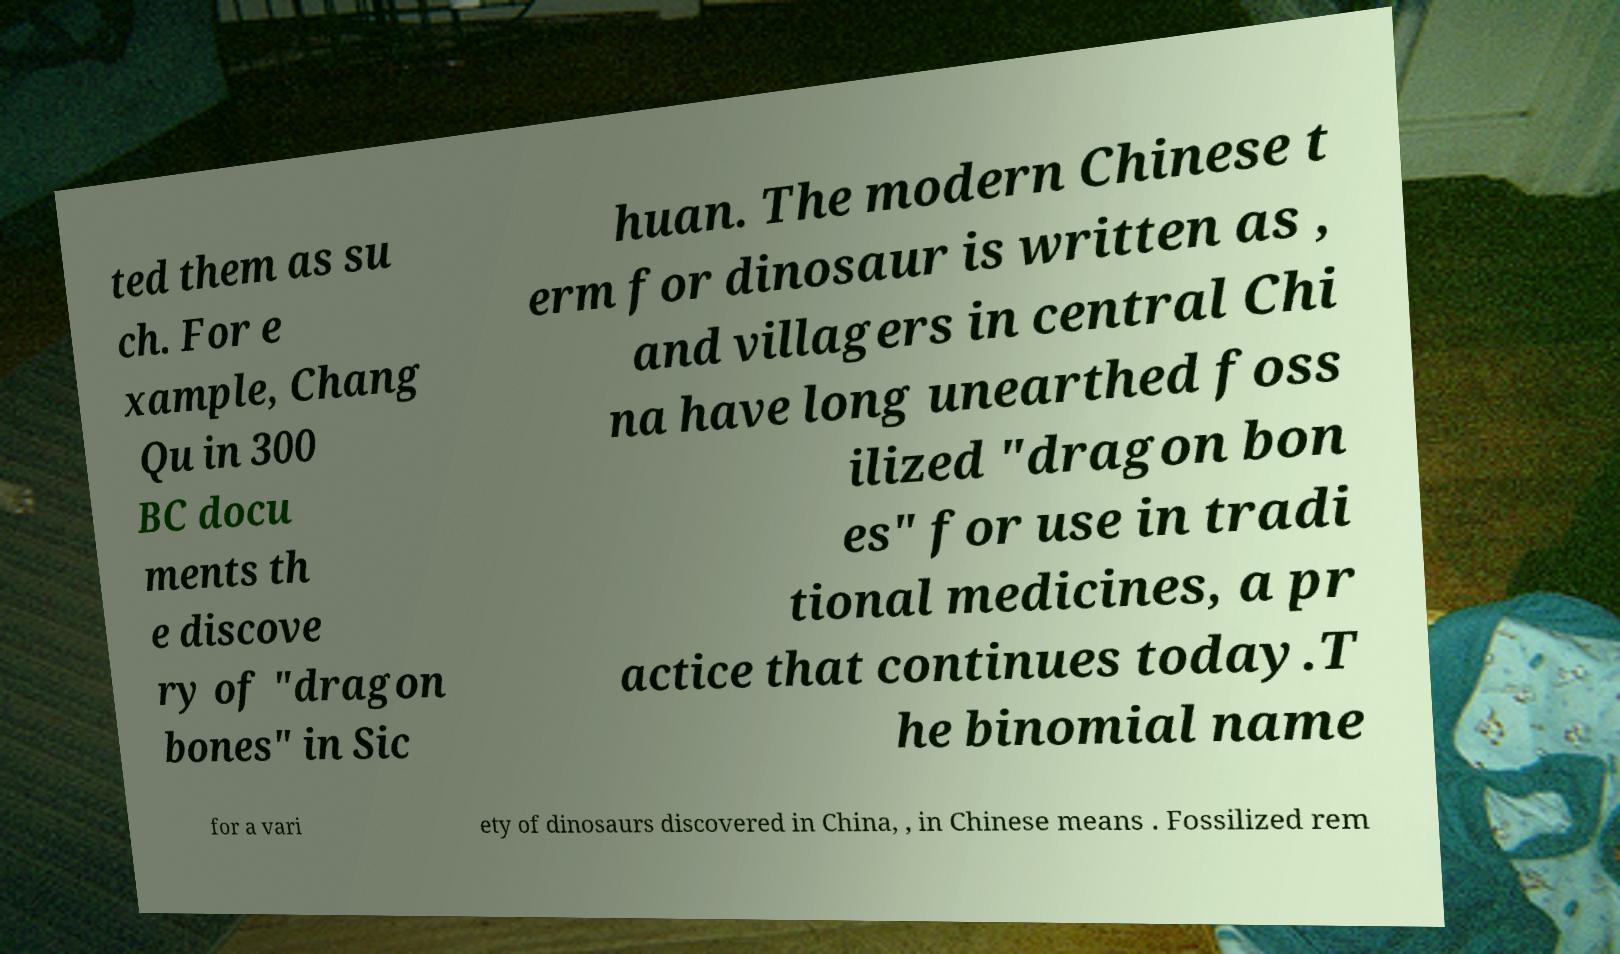Please read and relay the text visible in this image. What does it say? ted them as su ch. For e xample, Chang Qu in 300 BC docu ments th e discove ry of "dragon bones" in Sic huan. The modern Chinese t erm for dinosaur is written as , and villagers in central Chi na have long unearthed foss ilized "dragon bon es" for use in tradi tional medicines, a pr actice that continues today.T he binomial name for a vari ety of dinosaurs discovered in China, , in Chinese means . Fossilized rem 